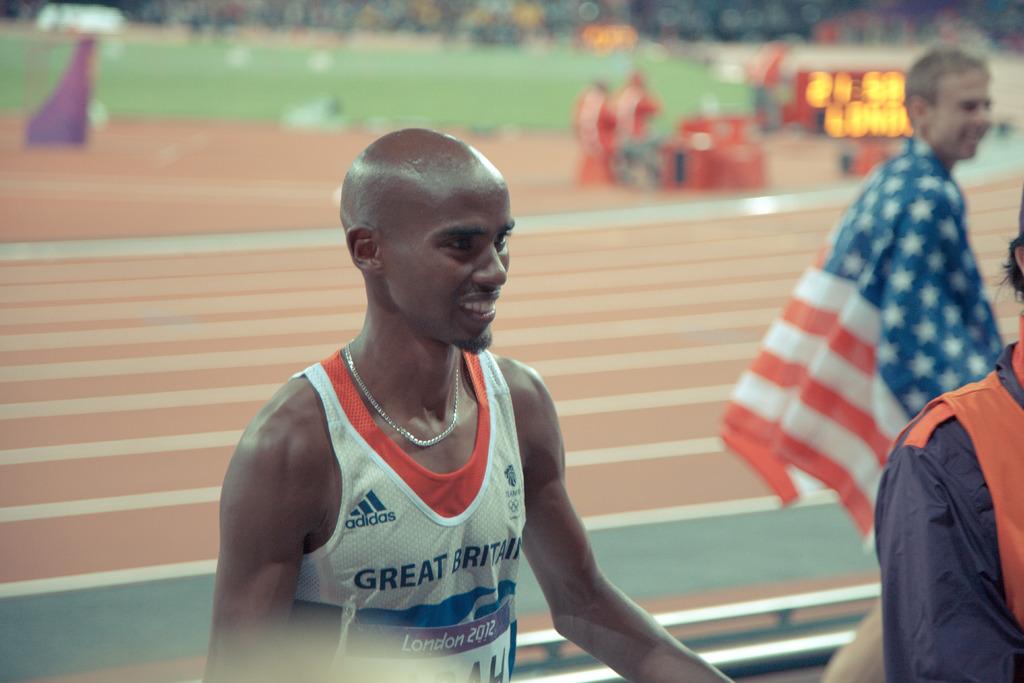What team is he on?
Offer a very short reply. Great britain. What type of athletic shoe is being sponsored on the mans shirt?
Your response must be concise. Adidas. 